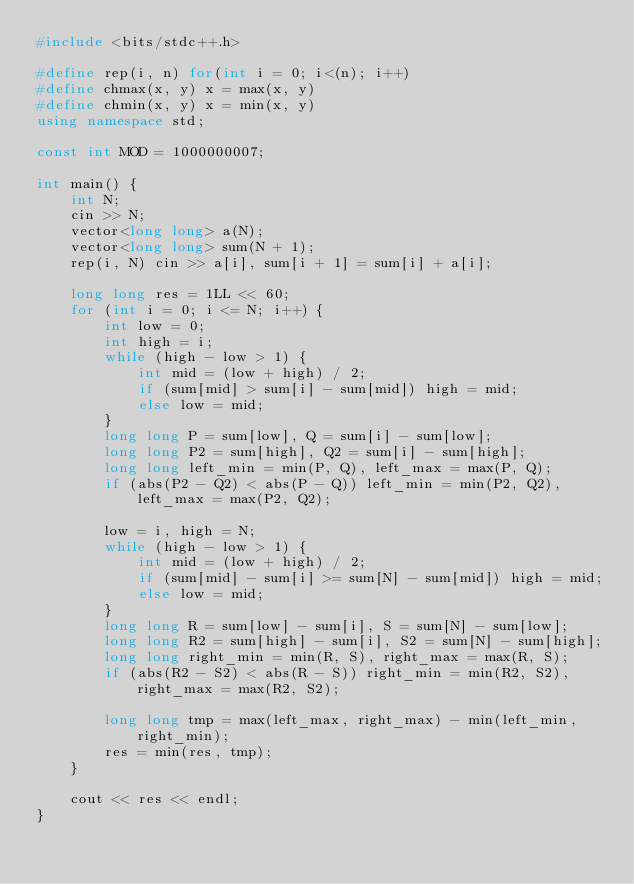Convert code to text. <code><loc_0><loc_0><loc_500><loc_500><_C++_>#include <bits/stdc++.h>

#define rep(i, n) for(int i = 0; i<(n); i++)
#define chmax(x, y) x = max(x, y)
#define chmin(x, y) x = min(x, y)
using namespace std;

const int MOD = 1000000007;

int main() {
    int N;
    cin >> N;
    vector<long long> a(N);
    vector<long long> sum(N + 1);
    rep(i, N) cin >> a[i], sum[i + 1] = sum[i] + a[i];

    long long res = 1LL << 60;
    for (int i = 0; i <= N; i++) {
        int low = 0;
        int high = i;
        while (high - low > 1) {
            int mid = (low + high) / 2;
            if (sum[mid] > sum[i] - sum[mid]) high = mid;
            else low = mid;
        }
        long long P = sum[low], Q = sum[i] - sum[low];
        long long P2 = sum[high], Q2 = sum[i] - sum[high];
        long long left_min = min(P, Q), left_max = max(P, Q);
        if (abs(P2 - Q2) < abs(P - Q)) left_min = min(P2, Q2), left_max = max(P2, Q2);

        low = i, high = N;
        while (high - low > 1) {
            int mid = (low + high) / 2;
            if (sum[mid] - sum[i] >= sum[N] - sum[mid]) high = mid;
            else low = mid;
        }
        long long R = sum[low] - sum[i], S = sum[N] - sum[low];
        long long R2 = sum[high] - sum[i], S2 = sum[N] - sum[high];
        long long right_min = min(R, S), right_max = max(R, S);
        if (abs(R2 - S2) < abs(R - S)) right_min = min(R2, S2), right_max = max(R2, S2);

        long long tmp = max(left_max, right_max) - min(left_min, right_min);
        res = min(res, tmp);
    }

    cout << res << endl;
}</code> 